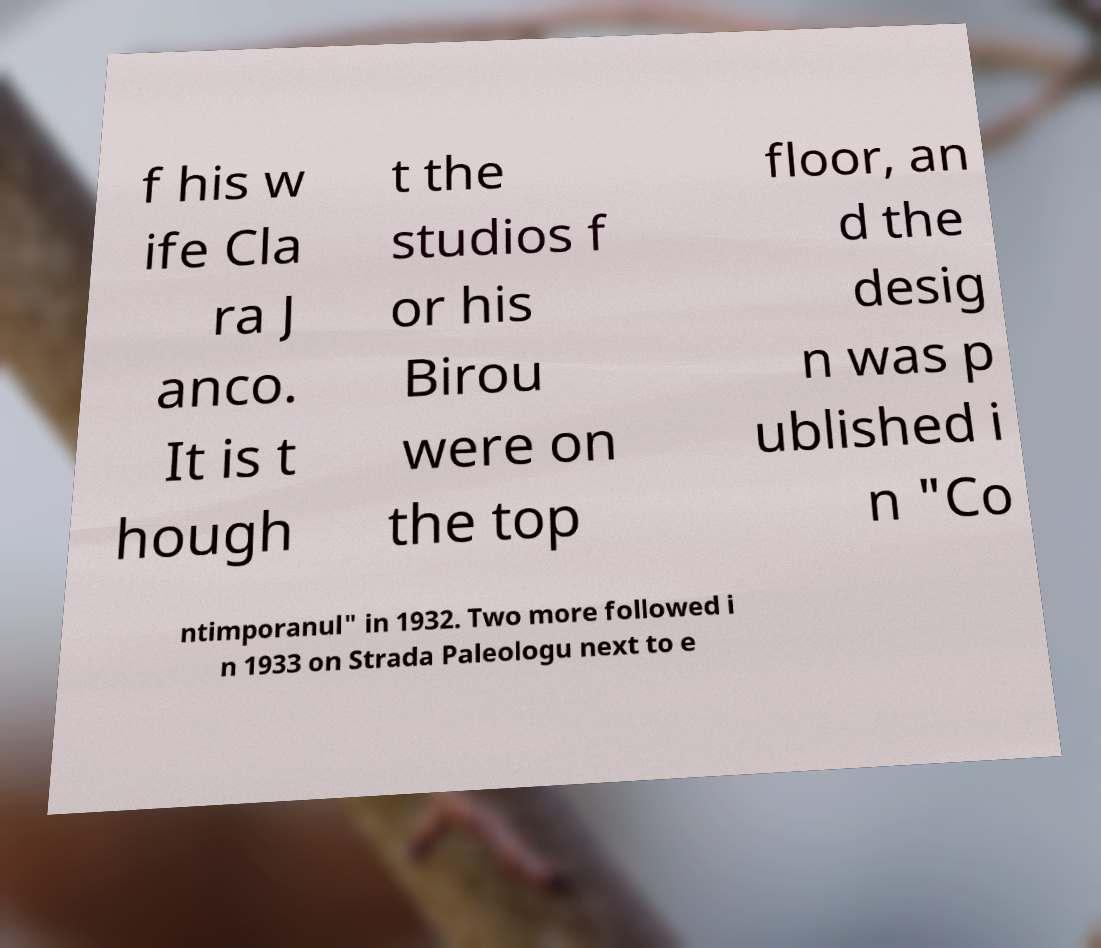Please identify and transcribe the text found in this image. f his w ife Cla ra J anco. It is t hough t the studios f or his Birou were on the top floor, an d the desig n was p ublished i n "Co ntimporanul" in 1932. Two more followed i n 1933 on Strada Paleologu next to e 